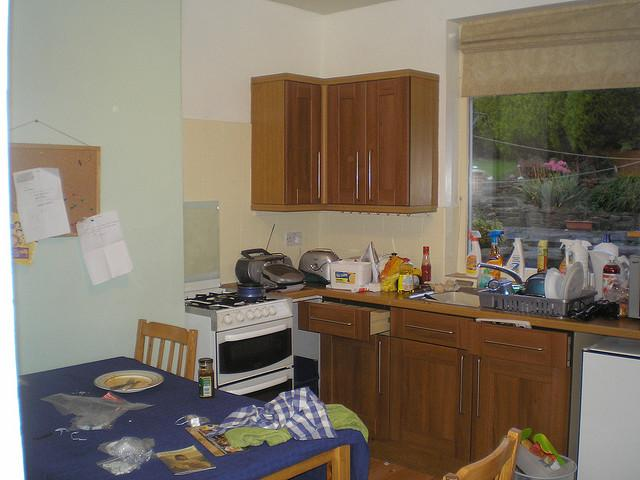What is the object with the metal rod on it?

Choices:
A) radio
B) coffee maker
C) tv
D) microwave radio 